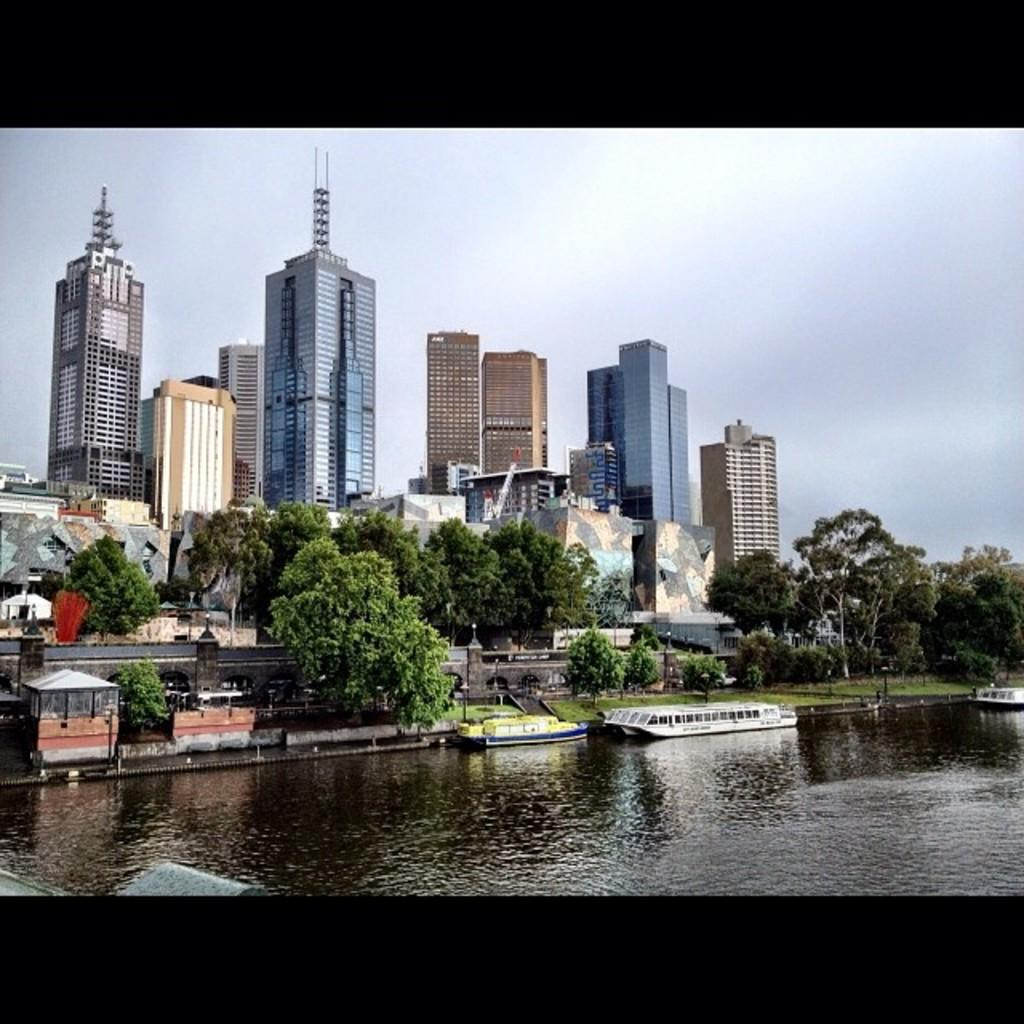What is the main feature of the image? The main feature of the image is water. What can be seen floating on the water? There are boats in the water. What type of vegetation is near the water? There are trees near the water. What type of structures are near the water? There are buildings near the water. What type of ground is visible in the image? There is a grass lawn in the image. What is visible in the background of the image? The sky is visible in the background of the image. What type of button can be seen being used for writing in the image? There is no button or writing present in the image. What type of coil can be seen in the image? There is no coil present in the image. 